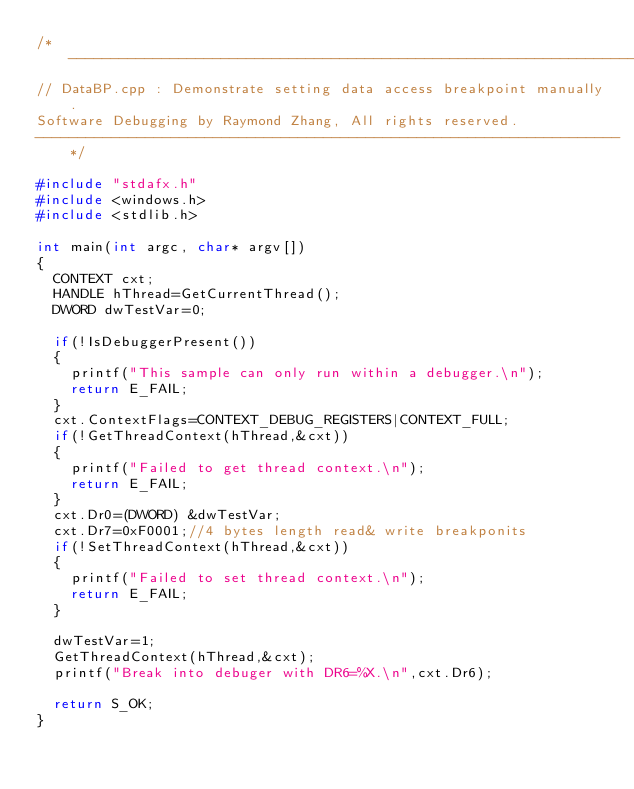<code> <loc_0><loc_0><loc_500><loc_500><_C++_>/*---------------------------------------------------------------------
// DataBP.cpp : Demonstrate setting data access breakpoint manually.
Software Debugging by Raymond Zhang, All rights reserved. 
---------------------------------------------------------------------*/

#include "stdafx.h"
#include <windows.h>
#include <stdlib.h>

int main(int argc, char* argv[])
{
	CONTEXT cxt;
	HANDLE hThread=GetCurrentThread();
	DWORD dwTestVar=0;

	if(!IsDebuggerPresent())
	{
		printf("This sample can only run within a debugger.\n");
		return E_FAIL;
	}
	cxt.ContextFlags=CONTEXT_DEBUG_REGISTERS|CONTEXT_FULL;
	if(!GetThreadContext(hThread,&cxt))
	{
		printf("Failed to get thread context.\n");
		return E_FAIL;
	}
	cxt.Dr0=(DWORD) &dwTestVar;
	cxt.Dr7=0xF0001;//4 bytes length read& write breakponits
	if(!SetThreadContext(hThread,&cxt))
	{
		printf("Failed to set thread context.\n");
		return E_FAIL;
	}

	dwTestVar=1;
	GetThreadContext(hThread,&cxt);
	printf("Break into debuger with DR6=%X.\n",cxt.Dr6);

	return S_OK;
}

</code> 